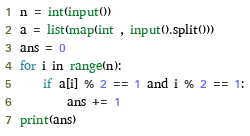Convert code to text. <code><loc_0><loc_0><loc_500><loc_500><_Python_>n = int(input())
a = list(map(int , input().split()))
ans = 0
for i in range(n):
    if a[i] % 2 == 1 and i % 2 == 1:
        ans += 1
print(ans)</code> 